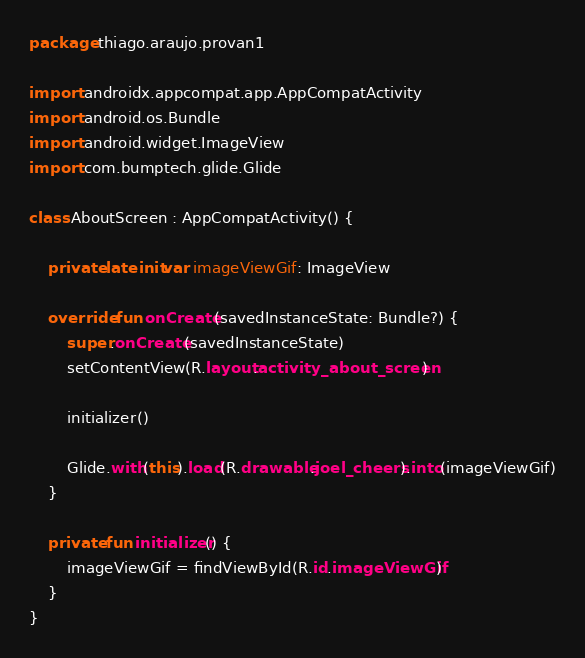<code> <loc_0><loc_0><loc_500><loc_500><_Kotlin_>package thiago.araujo.provan1

import androidx.appcompat.app.AppCompatActivity
import android.os.Bundle
import android.widget.ImageView
import com.bumptech.glide.Glide

class AboutScreen : AppCompatActivity() {

    private lateinit var imageViewGif: ImageView

    override fun onCreate(savedInstanceState: Bundle?) {
        super.onCreate(savedInstanceState)
        setContentView(R.layout.activity_about_screen)

        initializer()

        Glide.with(this).load(R.drawable.joel_cheers).into(imageViewGif)
    }

    private fun initializer() {
        imageViewGif = findViewById(R.id.imageViewGif)
    }
}</code> 